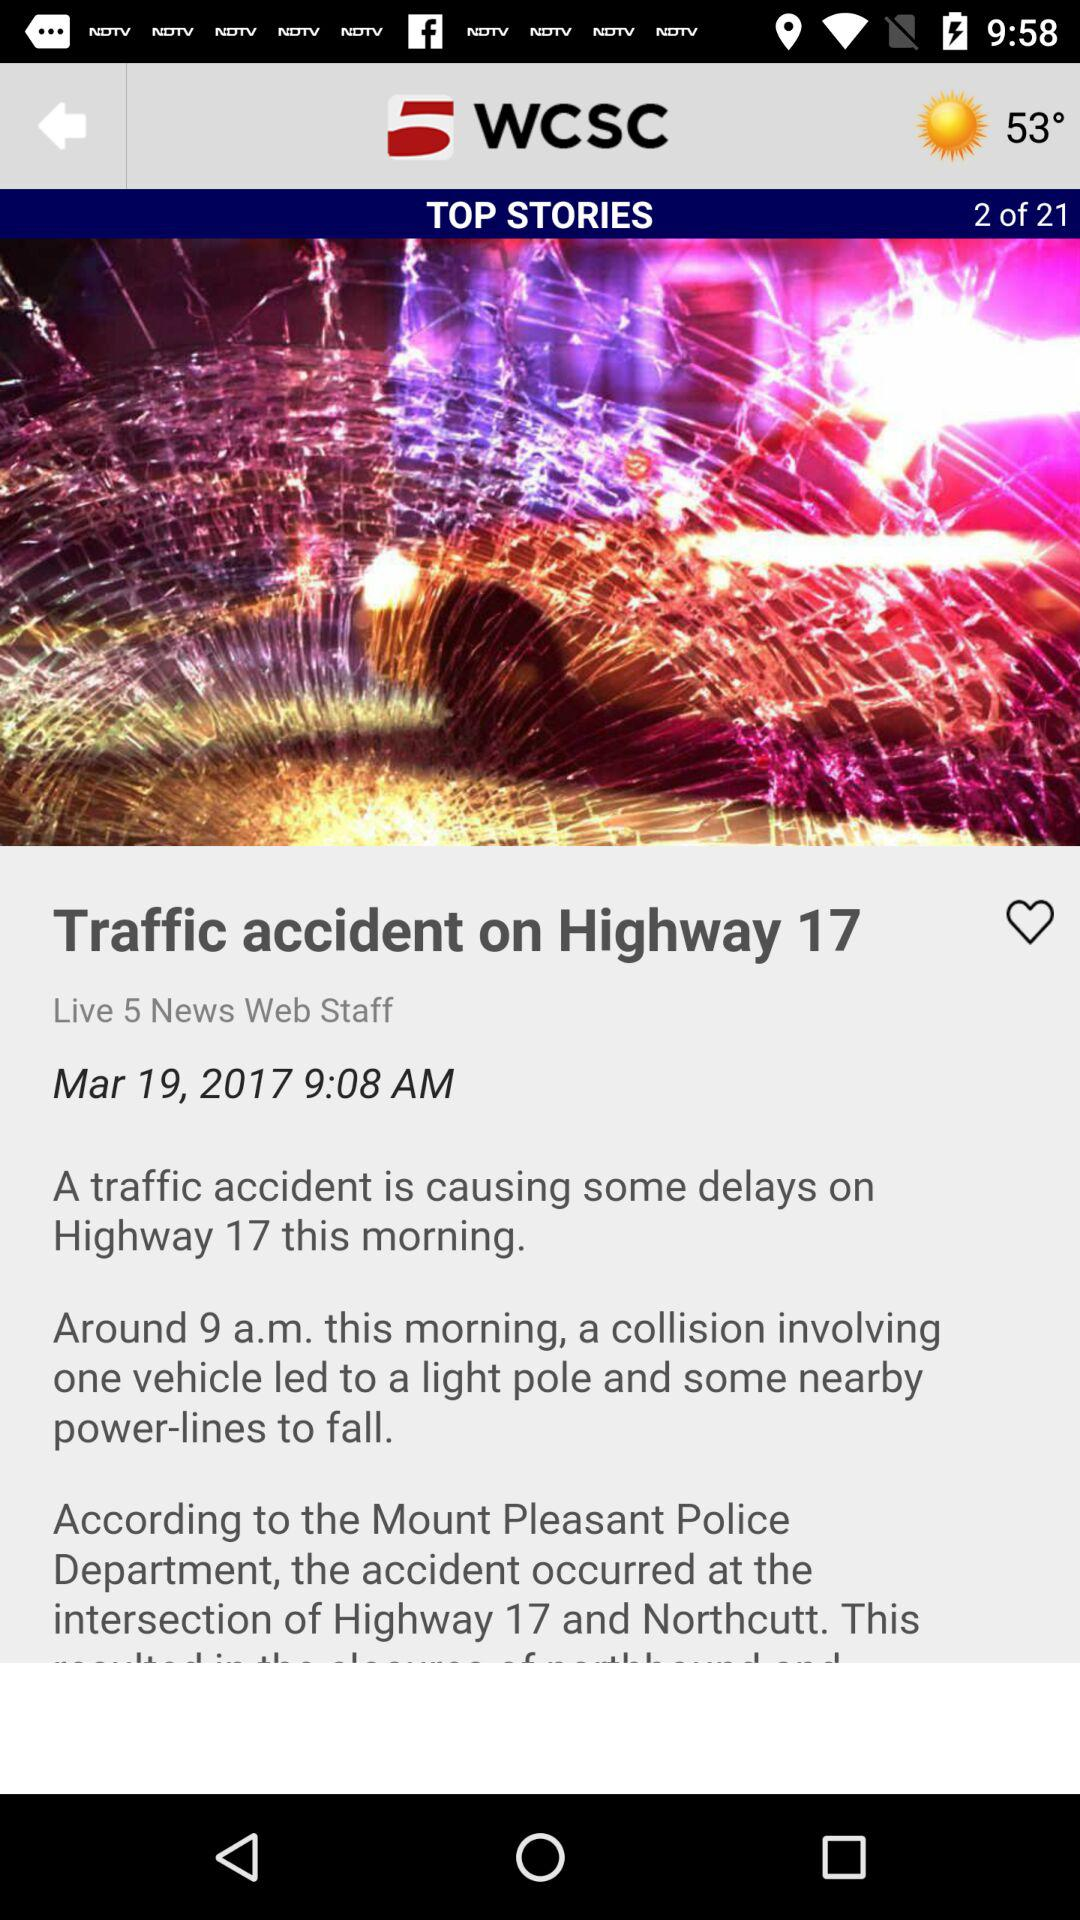What is the time? The time is 9:08 AM. 